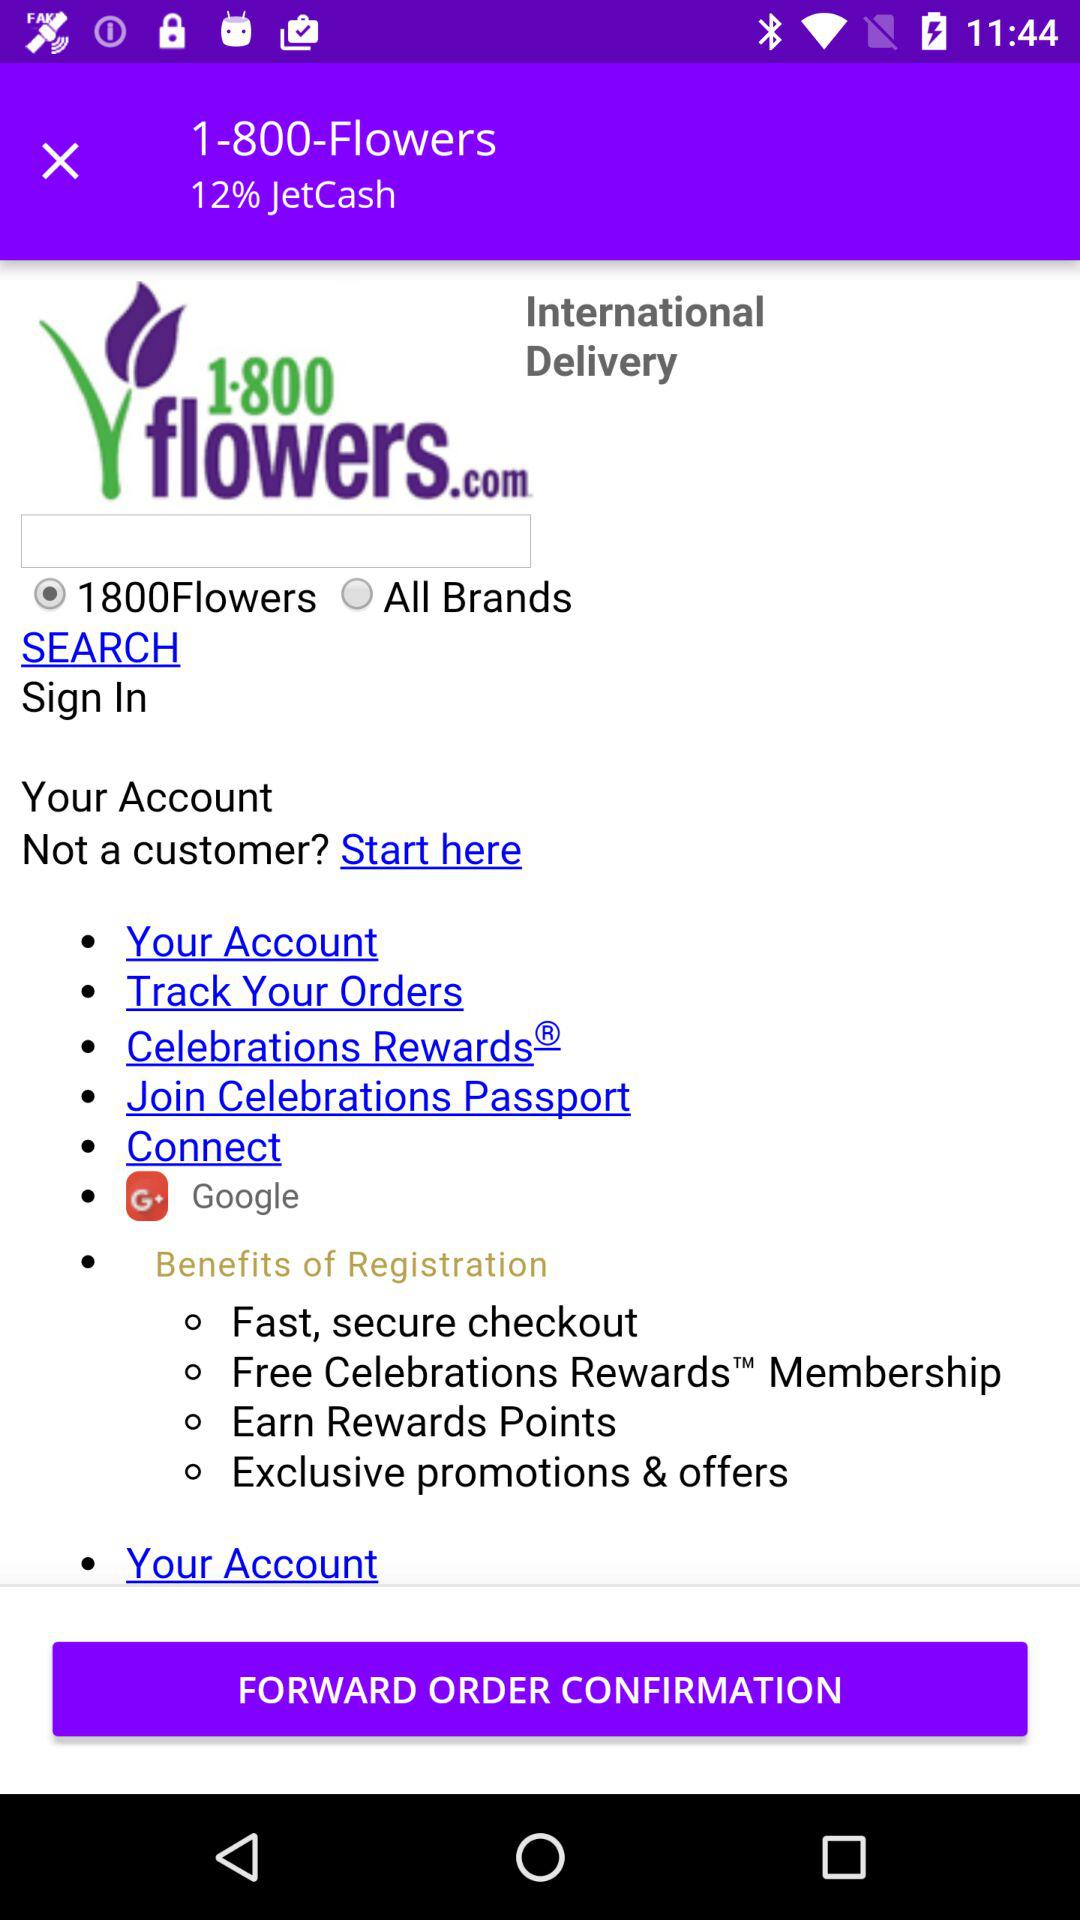What is the name of the application? The name of the application is "1-800-Flowers". 